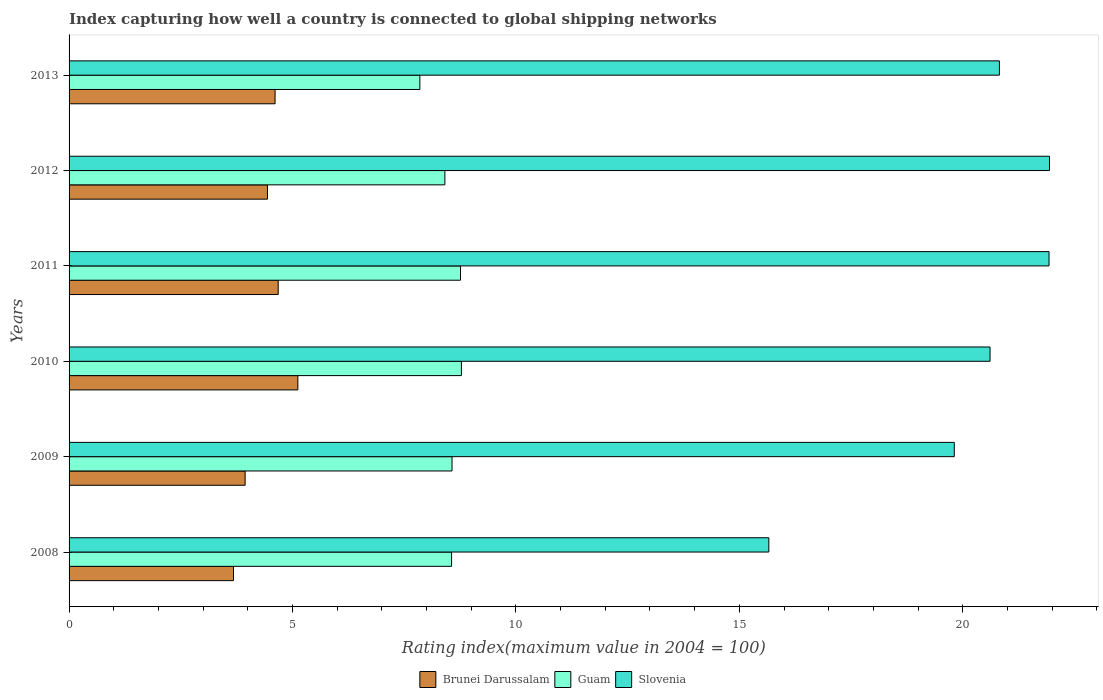How many groups of bars are there?
Give a very brief answer. 6. Are the number of bars per tick equal to the number of legend labels?
Your answer should be compact. Yes. Are the number of bars on each tick of the Y-axis equal?
Your answer should be very brief. Yes. How many bars are there on the 2nd tick from the top?
Ensure brevity in your answer.  3. What is the rating index in Guam in 2011?
Provide a short and direct response. 8.76. Across all years, what is the maximum rating index in Slovenia?
Keep it short and to the point. 21.94. Across all years, what is the minimum rating index in Slovenia?
Offer a very short reply. 15.66. In which year was the rating index in Guam minimum?
Keep it short and to the point. 2013. What is the total rating index in Guam in the graph?
Make the answer very short. 50.93. What is the difference between the rating index in Slovenia in 2010 and that in 2012?
Provide a short and direct response. -1.33. What is the difference between the rating index in Slovenia in 2010 and the rating index in Guam in 2013?
Make the answer very short. 12.76. What is the average rating index in Slovenia per year?
Your answer should be compact. 20.13. In how many years, is the rating index in Brunei Darussalam greater than 12 ?
Ensure brevity in your answer.  0. What is the ratio of the rating index in Slovenia in 2008 to that in 2011?
Offer a very short reply. 0.71. Is the difference between the rating index in Slovenia in 2008 and 2012 greater than the difference between the rating index in Brunei Darussalam in 2008 and 2012?
Your answer should be very brief. No. What is the difference between the highest and the second highest rating index in Guam?
Make the answer very short. 0.02. What is the difference between the highest and the lowest rating index in Guam?
Provide a short and direct response. 0.93. In how many years, is the rating index in Brunei Darussalam greater than the average rating index in Brunei Darussalam taken over all years?
Offer a terse response. 4. What does the 3rd bar from the top in 2012 represents?
Ensure brevity in your answer.  Brunei Darussalam. What does the 2nd bar from the bottom in 2010 represents?
Provide a succinct answer. Guam. Is it the case that in every year, the sum of the rating index in Slovenia and rating index in Brunei Darussalam is greater than the rating index in Guam?
Make the answer very short. Yes. How many bars are there?
Provide a short and direct response. 18. Are all the bars in the graph horizontal?
Offer a very short reply. Yes. What is the difference between two consecutive major ticks on the X-axis?
Ensure brevity in your answer.  5. Are the values on the major ticks of X-axis written in scientific E-notation?
Offer a terse response. No. Does the graph contain any zero values?
Provide a short and direct response. No. Where does the legend appear in the graph?
Keep it short and to the point. Bottom center. How are the legend labels stacked?
Your response must be concise. Horizontal. What is the title of the graph?
Offer a terse response. Index capturing how well a country is connected to global shipping networks. Does "Bermuda" appear as one of the legend labels in the graph?
Give a very brief answer. No. What is the label or title of the X-axis?
Your response must be concise. Rating index(maximum value in 2004 = 100). What is the Rating index(maximum value in 2004 = 100) in Brunei Darussalam in 2008?
Keep it short and to the point. 3.68. What is the Rating index(maximum value in 2004 = 100) of Guam in 2008?
Your answer should be very brief. 8.56. What is the Rating index(maximum value in 2004 = 100) of Slovenia in 2008?
Ensure brevity in your answer.  15.66. What is the Rating index(maximum value in 2004 = 100) of Brunei Darussalam in 2009?
Give a very brief answer. 3.94. What is the Rating index(maximum value in 2004 = 100) in Guam in 2009?
Your answer should be compact. 8.57. What is the Rating index(maximum value in 2004 = 100) in Slovenia in 2009?
Provide a succinct answer. 19.81. What is the Rating index(maximum value in 2004 = 100) of Brunei Darussalam in 2010?
Your answer should be very brief. 5.12. What is the Rating index(maximum value in 2004 = 100) in Guam in 2010?
Keep it short and to the point. 8.78. What is the Rating index(maximum value in 2004 = 100) of Slovenia in 2010?
Your answer should be compact. 20.61. What is the Rating index(maximum value in 2004 = 100) in Brunei Darussalam in 2011?
Your response must be concise. 4.68. What is the Rating index(maximum value in 2004 = 100) in Guam in 2011?
Give a very brief answer. 8.76. What is the Rating index(maximum value in 2004 = 100) in Slovenia in 2011?
Provide a short and direct response. 21.93. What is the Rating index(maximum value in 2004 = 100) in Brunei Darussalam in 2012?
Your answer should be compact. 4.44. What is the Rating index(maximum value in 2004 = 100) of Guam in 2012?
Give a very brief answer. 8.41. What is the Rating index(maximum value in 2004 = 100) of Slovenia in 2012?
Offer a very short reply. 21.94. What is the Rating index(maximum value in 2004 = 100) of Brunei Darussalam in 2013?
Your answer should be compact. 4.61. What is the Rating index(maximum value in 2004 = 100) in Guam in 2013?
Offer a very short reply. 7.85. What is the Rating index(maximum value in 2004 = 100) in Slovenia in 2013?
Your answer should be compact. 20.82. Across all years, what is the maximum Rating index(maximum value in 2004 = 100) of Brunei Darussalam?
Keep it short and to the point. 5.12. Across all years, what is the maximum Rating index(maximum value in 2004 = 100) of Guam?
Your response must be concise. 8.78. Across all years, what is the maximum Rating index(maximum value in 2004 = 100) of Slovenia?
Provide a short and direct response. 21.94. Across all years, what is the minimum Rating index(maximum value in 2004 = 100) of Brunei Darussalam?
Your response must be concise. 3.68. Across all years, what is the minimum Rating index(maximum value in 2004 = 100) in Guam?
Offer a terse response. 7.85. Across all years, what is the minimum Rating index(maximum value in 2004 = 100) of Slovenia?
Provide a short and direct response. 15.66. What is the total Rating index(maximum value in 2004 = 100) of Brunei Darussalam in the graph?
Provide a short and direct response. 26.47. What is the total Rating index(maximum value in 2004 = 100) in Guam in the graph?
Your answer should be very brief. 50.93. What is the total Rating index(maximum value in 2004 = 100) of Slovenia in the graph?
Ensure brevity in your answer.  120.77. What is the difference between the Rating index(maximum value in 2004 = 100) in Brunei Darussalam in 2008 and that in 2009?
Provide a short and direct response. -0.26. What is the difference between the Rating index(maximum value in 2004 = 100) of Guam in 2008 and that in 2009?
Make the answer very short. -0.01. What is the difference between the Rating index(maximum value in 2004 = 100) in Slovenia in 2008 and that in 2009?
Keep it short and to the point. -4.15. What is the difference between the Rating index(maximum value in 2004 = 100) of Brunei Darussalam in 2008 and that in 2010?
Your answer should be compact. -1.44. What is the difference between the Rating index(maximum value in 2004 = 100) in Guam in 2008 and that in 2010?
Provide a succinct answer. -0.22. What is the difference between the Rating index(maximum value in 2004 = 100) of Slovenia in 2008 and that in 2010?
Keep it short and to the point. -4.95. What is the difference between the Rating index(maximum value in 2004 = 100) of Slovenia in 2008 and that in 2011?
Ensure brevity in your answer.  -6.27. What is the difference between the Rating index(maximum value in 2004 = 100) of Brunei Darussalam in 2008 and that in 2012?
Offer a terse response. -0.76. What is the difference between the Rating index(maximum value in 2004 = 100) of Guam in 2008 and that in 2012?
Your answer should be compact. 0.15. What is the difference between the Rating index(maximum value in 2004 = 100) in Slovenia in 2008 and that in 2012?
Your answer should be compact. -6.28. What is the difference between the Rating index(maximum value in 2004 = 100) of Brunei Darussalam in 2008 and that in 2013?
Provide a short and direct response. -0.93. What is the difference between the Rating index(maximum value in 2004 = 100) of Guam in 2008 and that in 2013?
Your answer should be compact. 0.71. What is the difference between the Rating index(maximum value in 2004 = 100) in Slovenia in 2008 and that in 2013?
Give a very brief answer. -5.16. What is the difference between the Rating index(maximum value in 2004 = 100) of Brunei Darussalam in 2009 and that in 2010?
Ensure brevity in your answer.  -1.18. What is the difference between the Rating index(maximum value in 2004 = 100) of Guam in 2009 and that in 2010?
Ensure brevity in your answer.  -0.21. What is the difference between the Rating index(maximum value in 2004 = 100) in Brunei Darussalam in 2009 and that in 2011?
Offer a terse response. -0.74. What is the difference between the Rating index(maximum value in 2004 = 100) in Guam in 2009 and that in 2011?
Your answer should be very brief. -0.19. What is the difference between the Rating index(maximum value in 2004 = 100) of Slovenia in 2009 and that in 2011?
Offer a terse response. -2.12. What is the difference between the Rating index(maximum value in 2004 = 100) in Brunei Darussalam in 2009 and that in 2012?
Ensure brevity in your answer.  -0.5. What is the difference between the Rating index(maximum value in 2004 = 100) in Guam in 2009 and that in 2012?
Offer a terse response. 0.16. What is the difference between the Rating index(maximum value in 2004 = 100) in Slovenia in 2009 and that in 2012?
Give a very brief answer. -2.13. What is the difference between the Rating index(maximum value in 2004 = 100) of Brunei Darussalam in 2009 and that in 2013?
Your answer should be very brief. -0.67. What is the difference between the Rating index(maximum value in 2004 = 100) of Guam in 2009 and that in 2013?
Keep it short and to the point. 0.72. What is the difference between the Rating index(maximum value in 2004 = 100) of Slovenia in 2009 and that in 2013?
Your response must be concise. -1.01. What is the difference between the Rating index(maximum value in 2004 = 100) in Brunei Darussalam in 2010 and that in 2011?
Your response must be concise. 0.44. What is the difference between the Rating index(maximum value in 2004 = 100) in Guam in 2010 and that in 2011?
Your answer should be compact. 0.02. What is the difference between the Rating index(maximum value in 2004 = 100) in Slovenia in 2010 and that in 2011?
Provide a succinct answer. -1.32. What is the difference between the Rating index(maximum value in 2004 = 100) in Brunei Darussalam in 2010 and that in 2012?
Your response must be concise. 0.68. What is the difference between the Rating index(maximum value in 2004 = 100) in Guam in 2010 and that in 2012?
Your answer should be very brief. 0.37. What is the difference between the Rating index(maximum value in 2004 = 100) in Slovenia in 2010 and that in 2012?
Give a very brief answer. -1.33. What is the difference between the Rating index(maximum value in 2004 = 100) in Brunei Darussalam in 2010 and that in 2013?
Your response must be concise. 0.51. What is the difference between the Rating index(maximum value in 2004 = 100) of Guam in 2010 and that in 2013?
Your response must be concise. 0.93. What is the difference between the Rating index(maximum value in 2004 = 100) in Slovenia in 2010 and that in 2013?
Give a very brief answer. -0.21. What is the difference between the Rating index(maximum value in 2004 = 100) of Brunei Darussalam in 2011 and that in 2012?
Your response must be concise. 0.24. What is the difference between the Rating index(maximum value in 2004 = 100) in Slovenia in 2011 and that in 2012?
Your answer should be very brief. -0.01. What is the difference between the Rating index(maximum value in 2004 = 100) in Brunei Darussalam in 2011 and that in 2013?
Provide a short and direct response. 0.07. What is the difference between the Rating index(maximum value in 2004 = 100) of Guam in 2011 and that in 2013?
Keep it short and to the point. 0.91. What is the difference between the Rating index(maximum value in 2004 = 100) in Slovenia in 2011 and that in 2013?
Make the answer very short. 1.11. What is the difference between the Rating index(maximum value in 2004 = 100) in Brunei Darussalam in 2012 and that in 2013?
Give a very brief answer. -0.17. What is the difference between the Rating index(maximum value in 2004 = 100) in Guam in 2012 and that in 2013?
Make the answer very short. 0.56. What is the difference between the Rating index(maximum value in 2004 = 100) of Slovenia in 2012 and that in 2013?
Ensure brevity in your answer.  1.12. What is the difference between the Rating index(maximum value in 2004 = 100) of Brunei Darussalam in 2008 and the Rating index(maximum value in 2004 = 100) of Guam in 2009?
Your answer should be compact. -4.89. What is the difference between the Rating index(maximum value in 2004 = 100) in Brunei Darussalam in 2008 and the Rating index(maximum value in 2004 = 100) in Slovenia in 2009?
Your answer should be very brief. -16.13. What is the difference between the Rating index(maximum value in 2004 = 100) of Guam in 2008 and the Rating index(maximum value in 2004 = 100) of Slovenia in 2009?
Your answer should be very brief. -11.25. What is the difference between the Rating index(maximum value in 2004 = 100) in Brunei Darussalam in 2008 and the Rating index(maximum value in 2004 = 100) in Slovenia in 2010?
Give a very brief answer. -16.93. What is the difference between the Rating index(maximum value in 2004 = 100) in Guam in 2008 and the Rating index(maximum value in 2004 = 100) in Slovenia in 2010?
Your answer should be compact. -12.05. What is the difference between the Rating index(maximum value in 2004 = 100) in Brunei Darussalam in 2008 and the Rating index(maximum value in 2004 = 100) in Guam in 2011?
Offer a very short reply. -5.08. What is the difference between the Rating index(maximum value in 2004 = 100) in Brunei Darussalam in 2008 and the Rating index(maximum value in 2004 = 100) in Slovenia in 2011?
Make the answer very short. -18.25. What is the difference between the Rating index(maximum value in 2004 = 100) of Guam in 2008 and the Rating index(maximum value in 2004 = 100) of Slovenia in 2011?
Provide a short and direct response. -13.37. What is the difference between the Rating index(maximum value in 2004 = 100) of Brunei Darussalam in 2008 and the Rating index(maximum value in 2004 = 100) of Guam in 2012?
Make the answer very short. -4.73. What is the difference between the Rating index(maximum value in 2004 = 100) in Brunei Darussalam in 2008 and the Rating index(maximum value in 2004 = 100) in Slovenia in 2012?
Keep it short and to the point. -18.26. What is the difference between the Rating index(maximum value in 2004 = 100) of Guam in 2008 and the Rating index(maximum value in 2004 = 100) of Slovenia in 2012?
Your answer should be very brief. -13.38. What is the difference between the Rating index(maximum value in 2004 = 100) in Brunei Darussalam in 2008 and the Rating index(maximum value in 2004 = 100) in Guam in 2013?
Provide a short and direct response. -4.17. What is the difference between the Rating index(maximum value in 2004 = 100) of Brunei Darussalam in 2008 and the Rating index(maximum value in 2004 = 100) of Slovenia in 2013?
Offer a very short reply. -17.14. What is the difference between the Rating index(maximum value in 2004 = 100) in Guam in 2008 and the Rating index(maximum value in 2004 = 100) in Slovenia in 2013?
Offer a terse response. -12.26. What is the difference between the Rating index(maximum value in 2004 = 100) of Brunei Darussalam in 2009 and the Rating index(maximum value in 2004 = 100) of Guam in 2010?
Make the answer very short. -4.84. What is the difference between the Rating index(maximum value in 2004 = 100) of Brunei Darussalam in 2009 and the Rating index(maximum value in 2004 = 100) of Slovenia in 2010?
Your answer should be very brief. -16.67. What is the difference between the Rating index(maximum value in 2004 = 100) in Guam in 2009 and the Rating index(maximum value in 2004 = 100) in Slovenia in 2010?
Make the answer very short. -12.04. What is the difference between the Rating index(maximum value in 2004 = 100) in Brunei Darussalam in 2009 and the Rating index(maximum value in 2004 = 100) in Guam in 2011?
Keep it short and to the point. -4.82. What is the difference between the Rating index(maximum value in 2004 = 100) in Brunei Darussalam in 2009 and the Rating index(maximum value in 2004 = 100) in Slovenia in 2011?
Give a very brief answer. -17.99. What is the difference between the Rating index(maximum value in 2004 = 100) in Guam in 2009 and the Rating index(maximum value in 2004 = 100) in Slovenia in 2011?
Ensure brevity in your answer.  -13.36. What is the difference between the Rating index(maximum value in 2004 = 100) of Brunei Darussalam in 2009 and the Rating index(maximum value in 2004 = 100) of Guam in 2012?
Keep it short and to the point. -4.47. What is the difference between the Rating index(maximum value in 2004 = 100) in Brunei Darussalam in 2009 and the Rating index(maximum value in 2004 = 100) in Slovenia in 2012?
Ensure brevity in your answer.  -18. What is the difference between the Rating index(maximum value in 2004 = 100) of Guam in 2009 and the Rating index(maximum value in 2004 = 100) of Slovenia in 2012?
Provide a succinct answer. -13.37. What is the difference between the Rating index(maximum value in 2004 = 100) of Brunei Darussalam in 2009 and the Rating index(maximum value in 2004 = 100) of Guam in 2013?
Your answer should be very brief. -3.91. What is the difference between the Rating index(maximum value in 2004 = 100) in Brunei Darussalam in 2009 and the Rating index(maximum value in 2004 = 100) in Slovenia in 2013?
Keep it short and to the point. -16.88. What is the difference between the Rating index(maximum value in 2004 = 100) of Guam in 2009 and the Rating index(maximum value in 2004 = 100) of Slovenia in 2013?
Ensure brevity in your answer.  -12.25. What is the difference between the Rating index(maximum value in 2004 = 100) in Brunei Darussalam in 2010 and the Rating index(maximum value in 2004 = 100) in Guam in 2011?
Keep it short and to the point. -3.64. What is the difference between the Rating index(maximum value in 2004 = 100) of Brunei Darussalam in 2010 and the Rating index(maximum value in 2004 = 100) of Slovenia in 2011?
Provide a succinct answer. -16.81. What is the difference between the Rating index(maximum value in 2004 = 100) of Guam in 2010 and the Rating index(maximum value in 2004 = 100) of Slovenia in 2011?
Make the answer very short. -13.15. What is the difference between the Rating index(maximum value in 2004 = 100) in Brunei Darussalam in 2010 and the Rating index(maximum value in 2004 = 100) in Guam in 2012?
Make the answer very short. -3.29. What is the difference between the Rating index(maximum value in 2004 = 100) in Brunei Darussalam in 2010 and the Rating index(maximum value in 2004 = 100) in Slovenia in 2012?
Your response must be concise. -16.82. What is the difference between the Rating index(maximum value in 2004 = 100) of Guam in 2010 and the Rating index(maximum value in 2004 = 100) of Slovenia in 2012?
Offer a terse response. -13.16. What is the difference between the Rating index(maximum value in 2004 = 100) in Brunei Darussalam in 2010 and the Rating index(maximum value in 2004 = 100) in Guam in 2013?
Offer a terse response. -2.73. What is the difference between the Rating index(maximum value in 2004 = 100) in Brunei Darussalam in 2010 and the Rating index(maximum value in 2004 = 100) in Slovenia in 2013?
Offer a terse response. -15.7. What is the difference between the Rating index(maximum value in 2004 = 100) in Guam in 2010 and the Rating index(maximum value in 2004 = 100) in Slovenia in 2013?
Make the answer very short. -12.04. What is the difference between the Rating index(maximum value in 2004 = 100) of Brunei Darussalam in 2011 and the Rating index(maximum value in 2004 = 100) of Guam in 2012?
Ensure brevity in your answer.  -3.73. What is the difference between the Rating index(maximum value in 2004 = 100) in Brunei Darussalam in 2011 and the Rating index(maximum value in 2004 = 100) in Slovenia in 2012?
Provide a short and direct response. -17.26. What is the difference between the Rating index(maximum value in 2004 = 100) of Guam in 2011 and the Rating index(maximum value in 2004 = 100) of Slovenia in 2012?
Keep it short and to the point. -13.18. What is the difference between the Rating index(maximum value in 2004 = 100) in Brunei Darussalam in 2011 and the Rating index(maximum value in 2004 = 100) in Guam in 2013?
Your response must be concise. -3.17. What is the difference between the Rating index(maximum value in 2004 = 100) in Brunei Darussalam in 2011 and the Rating index(maximum value in 2004 = 100) in Slovenia in 2013?
Provide a succinct answer. -16.14. What is the difference between the Rating index(maximum value in 2004 = 100) of Guam in 2011 and the Rating index(maximum value in 2004 = 100) of Slovenia in 2013?
Keep it short and to the point. -12.06. What is the difference between the Rating index(maximum value in 2004 = 100) in Brunei Darussalam in 2012 and the Rating index(maximum value in 2004 = 100) in Guam in 2013?
Give a very brief answer. -3.41. What is the difference between the Rating index(maximum value in 2004 = 100) of Brunei Darussalam in 2012 and the Rating index(maximum value in 2004 = 100) of Slovenia in 2013?
Ensure brevity in your answer.  -16.38. What is the difference between the Rating index(maximum value in 2004 = 100) in Guam in 2012 and the Rating index(maximum value in 2004 = 100) in Slovenia in 2013?
Your answer should be compact. -12.41. What is the average Rating index(maximum value in 2004 = 100) in Brunei Darussalam per year?
Make the answer very short. 4.41. What is the average Rating index(maximum value in 2004 = 100) in Guam per year?
Provide a succinct answer. 8.49. What is the average Rating index(maximum value in 2004 = 100) of Slovenia per year?
Your response must be concise. 20.13. In the year 2008, what is the difference between the Rating index(maximum value in 2004 = 100) of Brunei Darussalam and Rating index(maximum value in 2004 = 100) of Guam?
Your response must be concise. -4.88. In the year 2008, what is the difference between the Rating index(maximum value in 2004 = 100) in Brunei Darussalam and Rating index(maximum value in 2004 = 100) in Slovenia?
Provide a short and direct response. -11.98. In the year 2009, what is the difference between the Rating index(maximum value in 2004 = 100) in Brunei Darussalam and Rating index(maximum value in 2004 = 100) in Guam?
Provide a short and direct response. -4.63. In the year 2009, what is the difference between the Rating index(maximum value in 2004 = 100) in Brunei Darussalam and Rating index(maximum value in 2004 = 100) in Slovenia?
Give a very brief answer. -15.87. In the year 2009, what is the difference between the Rating index(maximum value in 2004 = 100) in Guam and Rating index(maximum value in 2004 = 100) in Slovenia?
Give a very brief answer. -11.24. In the year 2010, what is the difference between the Rating index(maximum value in 2004 = 100) of Brunei Darussalam and Rating index(maximum value in 2004 = 100) of Guam?
Offer a terse response. -3.66. In the year 2010, what is the difference between the Rating index(maximum value in 2004 = 100) of Brunei Darussalam and Rating index(maximum value in 2004 = 100) of Slovenia?
Offer a terse response. -15.49. In the year 2010, what is the difference between the Rating index(maximum value in 2004 = 100) of Guam and Rating index(maximum value in 2004 = 100) of Slovenia?
Your answer should be very brief. -11.83. In the year 2011, what is the difference between the Rating index(maximum value in 2004 = 100) in Brunei Darussalam and Rating index(maximum value in 2004 = 100) in Guam?
Provide a succinct answer. -4.08. In the year 2011, what is the difference between the Rating index(maximum value in 2004 = 100) in Brunei Darussalam and Rating index(maximum value in 2004 = 100) in Slovenia?
Give a very brief answer. -17.25. In the year 2011, what is the difference between the Rating index(maximum value in 2004 = 100) of Guam and Rating index(maximum value in 2004 = 100) of Slovenia?
Offer a very short reply. -13.17. In the year 2012, what is the difference between the Rating index(maximum value in 2004 = 100) in Brunei Darussalam and Rating index(maximum value in 2004 = 100) in Guam?
Provide a succinct answer. -3.97. In the year 2012, what is the difference between the Rating index(maximum value in 2004 = 100) of Brunei Darussalam and Rating index(maximum value in 2004 = 100) of Slovenia?
Offer a very short reply. -17.5. In the year 2012, what is the difference between the Rating index(maximum value in 2004 = 100) of Guam and Rating index(maximum value in 2004 = 100) of Slovenia?
Keep it short and to the point. -13.53. In the year 2013, what is the difference between the Rating index(maximum value in 2004 = 100) in Brunei Darussalam and Rating index(maximum value in 2004 = 100) in Guam?
Offer a very short reply. -3.24. In the year 2013, what is the difference between the Rating index(maximum value in 2004 = 100) in Brunei Darussalam and Rating index(maximum value in 2004 = 100) in Slovenia?
Give a very brief answer. -16.21. In the year 2013, what is the difference between the Rating index(maximum value in 2004 = 100) of Guam and Rating index(maximum value in 2004 = 100) of Slovenia?
Make the answer very short. -12.97. What is the ratio of the Rating index(maximum value in 2004 = 100) in Brunei Darussalam in 2008 to that in 2009?
Provide a short and direct response. 0.93. What is the ratio of the Rating index(maximum value in 2004 = 100) of Guam in 2008 to that in 2009?
Keep it short and to the point. 1. What is the ratio of the Rating index(maximum value in 2004 = 100) in Slovenia in 2008 to that in 2009?
Provide a succinct answer. 0.79. What is the ratio of the Rating index(maximum value in 2004 = 100) of Brunei Darussalam in 2008 to that in 2010?
Make the answer very short. 0.72. What is the ratio of the Rating index(maximum value in 2004 = 100) of Guam in 2008 to that in 2010?
Ensure brevity in your answer.  0.97. What is the ratio of the Rating index(maximum value in 2004 = 100) of Slovenia in 2008 to that in 2010?
Your response must be concise. 0.76. What is the ratio of the Rating index(maximum value in 2004 = 100) in Brunei Darussalam in 2008 to that in 2011?
Keep it short and to the point. 0.79. What is the ratio of the Rating index(maximum value in 2004 = 100) of Guam in 2008 to that in 2011?
Offer a terse response. 0.98. What is the ratio of the Rating index(maximum value in 2004 = 100) in Slovenia in 2008 to that in 2011?
Keep it short and to the point. 0.71. What is the ratio of the Rating index(maximum value in 2004 = 100) in Brunei Darussalam in 2008 to that in 2012?
Keep it short and to the point. 0.83. What is the ratio of the Rating index(maximum value in 2004 = 100) of Guam in 2008 to that in 2012?
Offer a very short reply. 1.02. What is the ratio of the Rating index(maximum value in 2004 = 100) in Slovenia in 2008 to that in 2012?
Give a very brief answer. 0.71. What is the ratio of the Rating index(maximum value in 2004 = 100) of Brunei Darussalam in 2008 to that in 2013?
Give a very brief answer. 0.8. What is the ratio of the Rating index(maximum value in 2004 = 100) in Guam in 2008 to that in 2013?
Give a very brief answer. 1.09. What is the ratio of the Rating index(maximum value in 2004 = 100) of Slovenia in 2008 to that in 2013?
Give a very brief answer. 0.75. What is the ratio of the Rating index(maximum value in 2004 = 100) in Brunei Darussalam in 2009 to that in 2010?
Your answer should be compact. 0.77. What is the ratio of the Rating index(maximum value in 2004 = 100) in Guam in 2009 to that in 2010?
Provide a short and direct response. 0.98. What is the ratio of the Rating index(maximum value in 2004 = 100) in Slovenia in 2009 to that in 2010?
Provide a succinct answer. 0.96. What is the ratio of the Rating index(maximum value in 2004 = 100) in Brunei Darussalam in 2009 to that in 2011?
Your response must be concise. 0.84. What is the ratio of the Rating index(maximum value in 2004 = 100) in Guam in 2009 to that in 2011?
Your answer should be compact. 0.98. What is the ratio of the Rating index(maximum value in 2004 = 100) in Slovenia in 2009 to that in 2011?
Give a very brief answer. 0.9. What is the ratio of the Rating index(maximum value in 2004 = 100) of Brunei Darussalam in 2009 to that in 2012?
Your response must be concise. 0.89. What is the ratio of the Rating index(maximum value in 2004 = 100) of Slovenia in 2009 to that in 2012?
Make the answer very short. 0.9. What is the ratio of the Rating index(maximum value in 2004 = 100) of Brunei Darussalam in 2009 to that in 2013?
Your response must be concise. 0.85. What is the ratio of the Rating index(maximum value in 2004 = 100) of Guam in 2009 to that in 2013?
Make the answer very short. 1.09. What is the ratio of the Rating index(maximum value in 2004 = 100) in Slovenia in 2009 to that in 2013?
Make the answer very short. 0.95. What is the ratio of the Rating index(maximum value in 2004 = 100) in Brunei Darussalam in 2010 to that in 2011?
Your response must be concise. 1.09. What is the ratio of the Rating index(maximum value in 2004 = 100) in Slovenia in 2010 to that in 2011?
Keep it short and to the point. 0.94. What is the ratio of the Rating index(maximum value in 2004 = 100) in Brunei Darussalam in 2010 to that in 2012?
Offer a very short reply. 1.15. What is the ratio of the Rating index(maximum value in 2004 = 100) of Guam in 2010 to that in 2012?
Provide a short and direct response. 1.04. What is the ratio of the Rating index(maximum value in 2004 = 100) of Slovenia in 2010 to that in 2012?
Give a very brief answer. 0.94. What is the ratio of the Rating index(maximum value in 2004 = 100) in Brunei Darussalam in 2010 to that in 2013?
Your answer should be very brief. 1.11. What is the ratio of the Rating index(maximum value in 2004 = 100) in Guam in 2010 to that in 2013?
Ensure brevity in your answer.  1.12. What is the ratio of the Rating index(maximum value in 2004 = 100) in Brunei Darussalam in 2011 to that in 2012?
Offer a very short reply. 1.05. What is the ratio of the Rating index(maximum value in 2004 = 100) in Guam in 2011 to that in 2012?
Offer a very short reply. 1.04. What is the ratio of the Rating index(maximum value in 2004 = 100) of Brunei Darussalam in 2011 to that in 2013?
Ensure brevity in your answer.  1.02. What is the ratio of the Rating index(maximum value in 2004 = 100) in Guam in 2011 to that in 2013?
Offer a very short reply. 1.12. What is the ratio of the Rating index(maximum value in 2004 = 100) of Slovenia in 2011 to that in 2013?
Give a very brief answer. 1.05. What is the ratio of the Rating index(maximum value in 2004 = 100) of Brunei Darussalam in 2012 to that in 2013?
Ensure brevity in your answer.  0.96. What is the ratio of the Rating index(maximum value in 2004 = 100) in Guam in 2012 to that in 2013?
Provide a succinct answer. 1.07. What is the ratio of the Rating index(maximum value in 2004 = 100) in Slovenia in 2012 to that in 2013?
Keep it short and to the point. 1.05. What is the difference between the highest and the second highest Rating index(maximum value in 2004 = 100) in Brunei Darussalam?
Provide a succinct answer. 0.44. What is the difference between the highest and the lowest Rating index(maximum value in 2004 = 100) of Brunei Darussalam?
Your answer should be compact. 1.44. What is the difference between the highest and the lowest Rating index(maximum value in 2004 = 100) in Guam?
Your response must be concise. 0.93. What is the difference between the highest and the lowest Rating index(maximum value in 2004 = 100) of Slovenia?
Give a very brief answer. 6.28. 